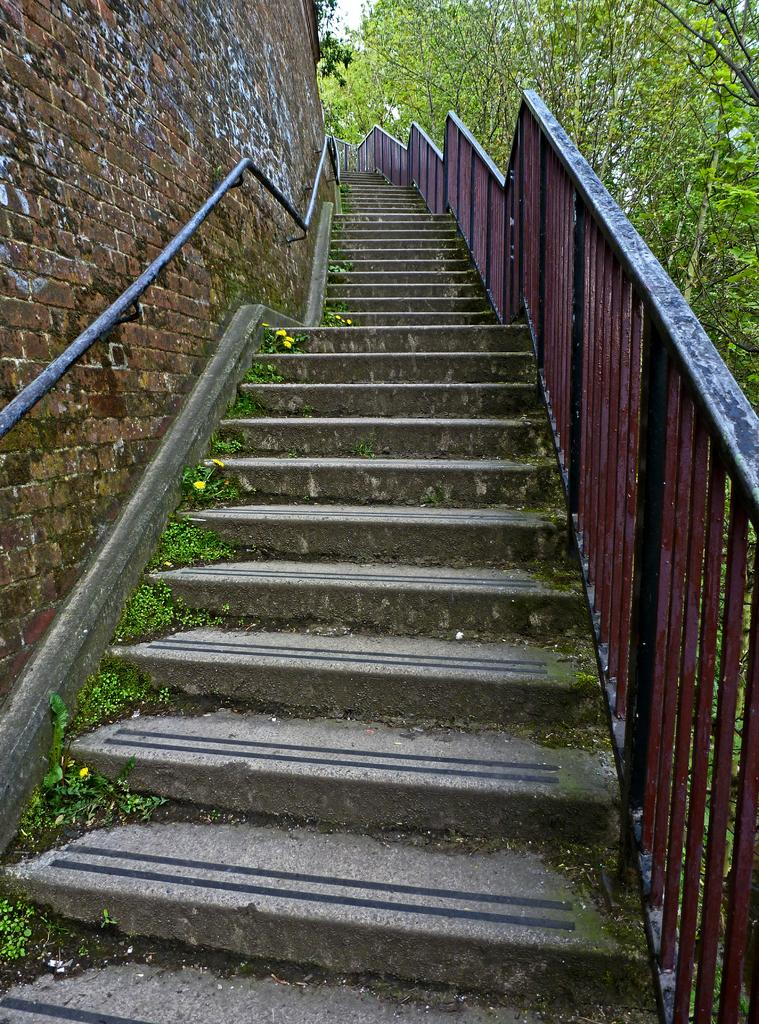What architectural feature is present in the image? There are steps in the image. What can be seen on the right side of the image? There is a railing and trees on the right side of the image. What is on the left side of the image? There is a wall on the left side of the image. What type of books can be seen in the library in the image? There is no library present in the image; it features steps, a railing, trees, and a wall. How many sacks are visible on the seashore in the image? There is no seashore or sacks present in the image. 